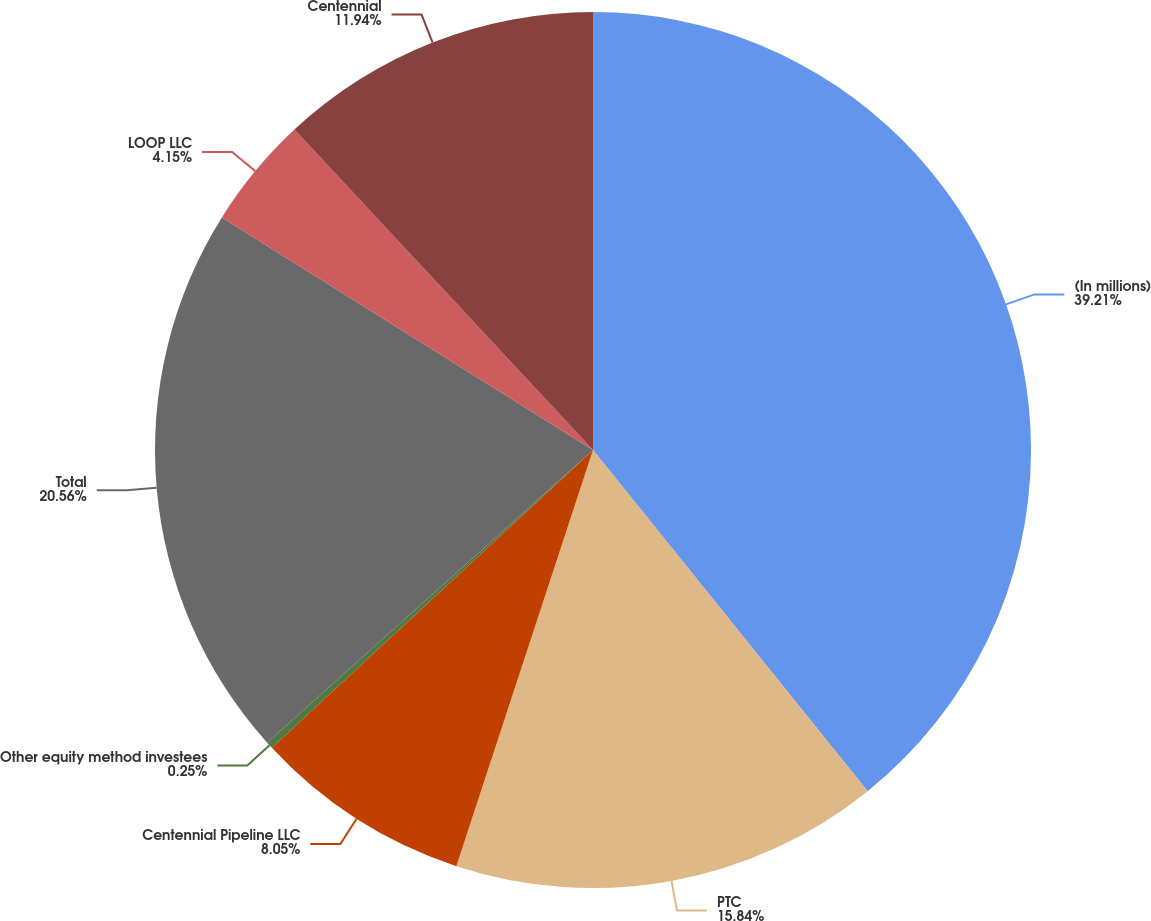Convert chart. <chart><loc_0><loc_0><loc_500><loc_500><pie_chart><fcel>(In millions)<fcel>PTC<fcel>Centennial Pipeline LLC<fcel>Other equity method investees<fcel>Total<fcel>LOOP LLC<fcel>Centennial<nl><fcel>39.21%<fcel>15.84%<fcel>8.05%<fcel>0.25%<fcel>20.56%<fcel>4.15%<fcel>11.94%<nl></chart> 